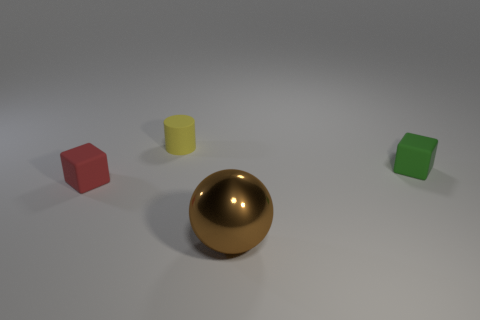Are there any small rubber things of the same shape as the large metal thing?
Offer a very short reply. No. Does the small thing that is on the left side of the yellow thing have the same color as the small object that is behind the green matte block?
Your response must be concise. No. Are there any tiny objects left of the big brown sphere?
Make the answer very short. Yes. What material is the small thing that is on the left side of the large brown ball and in front of the yellow matte thing?
Provide a succinct answer. Rubber. Is the material of the object that is to the left of the tiny yellow cylinder the same as the green block?
Your answer should be very brief. Yes. What is the material of the tiny cylinder?
Give a very brief answer. Rubber. What is the size of the rubber object right of the big ball?
Keep it short and to the point. Small. Is there anything else of the same color as the small cylinder?
Offer a very short reply. No. There is a rubber object that is in front of the matte cube that is right of the small yellow object; are there any balls that are on the left side of it?
Give a very brief answer. No. Is the color of the cube behind the tiny red rubber cube the same as the shiny thing?
Give a very brief answer. No. 